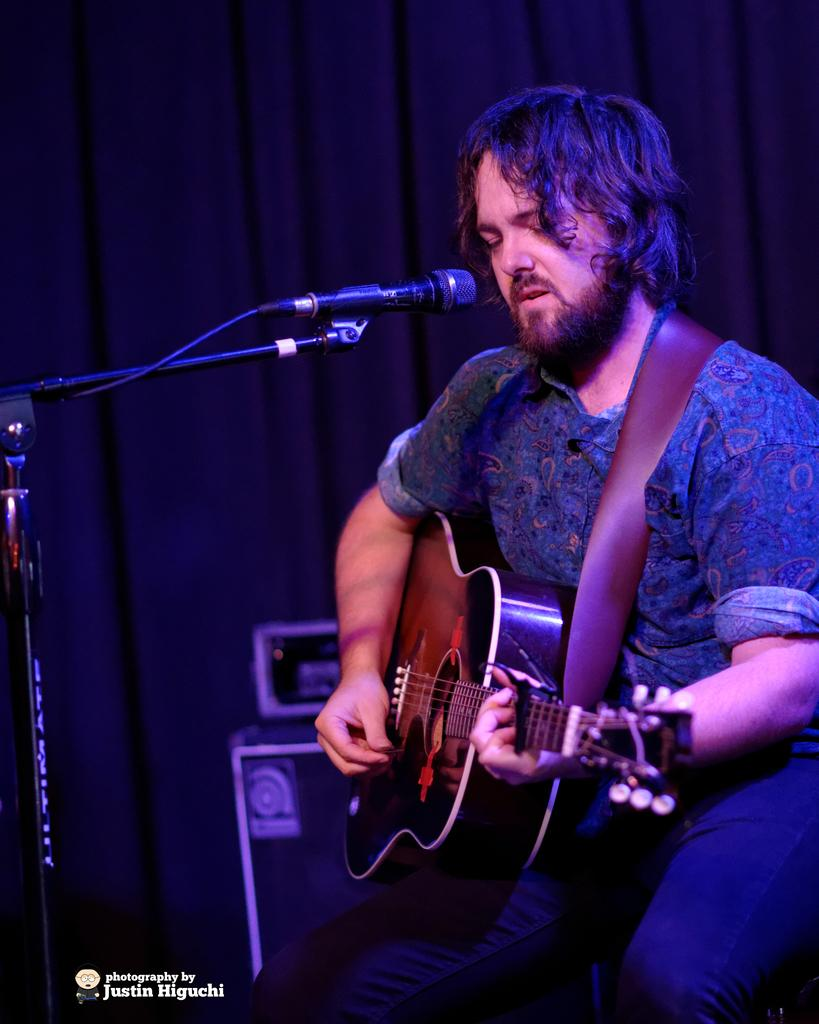What is the man in the image doing? The man is sitting, holding a guitar, and singing. What object is the man holding in the image? The man is holding a guitar in the image. What can be seen near the man in the image? There is a black color microphone in the image. What is visible in the background of the image? There is a curtain in the background of the image. How many pizzas are on the table in the image? There are no pizzas present in the image. What type of cherry is being used as a decoration in the image? There is no cherry present in the image. 